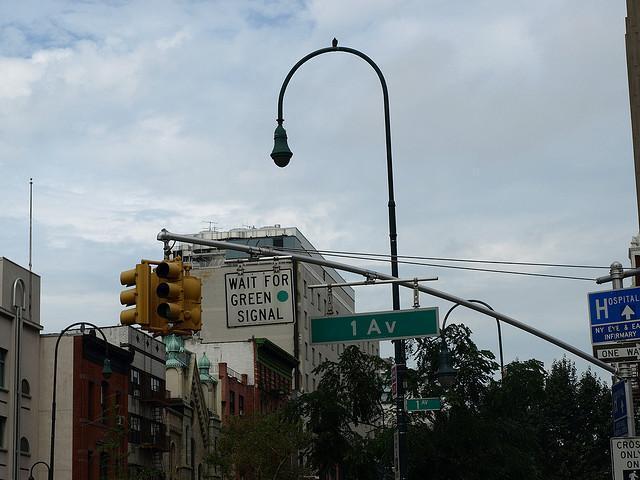How many birds are there?
Give a very brief answer. 0. 